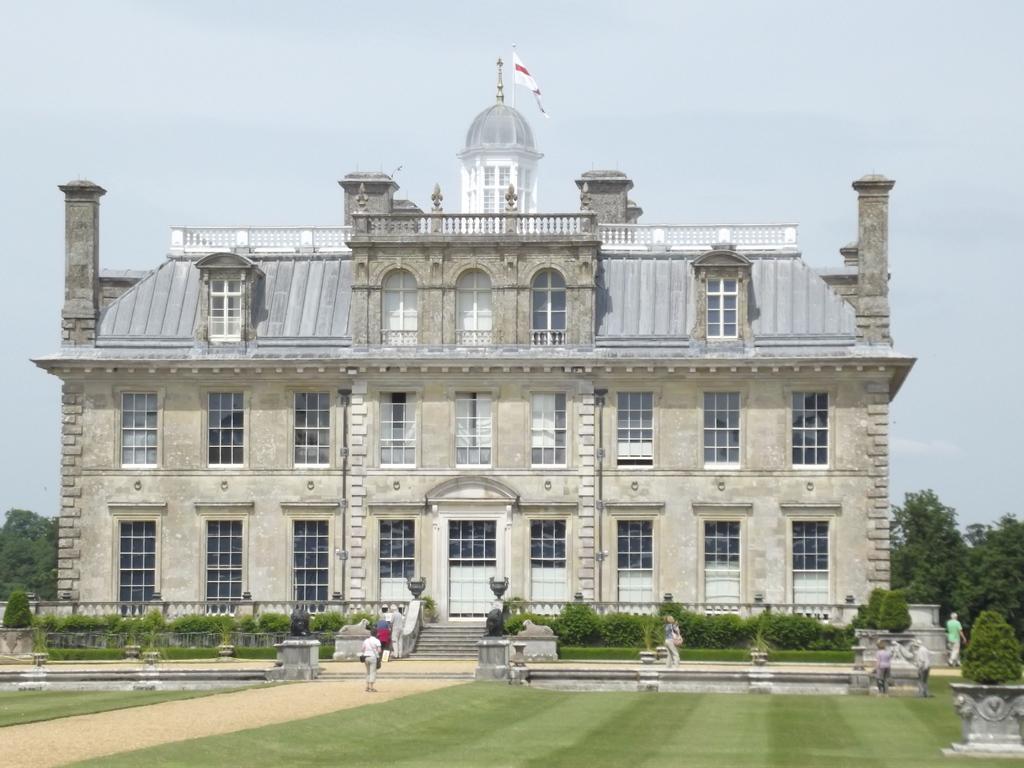Describe this image in one or two sentences. This picture is clicked outside. In the foreground we can see the green grass, plants, group of people and some other items and we can see the sculptures of some animals. In the center we can see the building and we can see the dome and the flag. In the background we can see the sky and the trees and we can see the stairs, railing and the windows and doors of the building. 